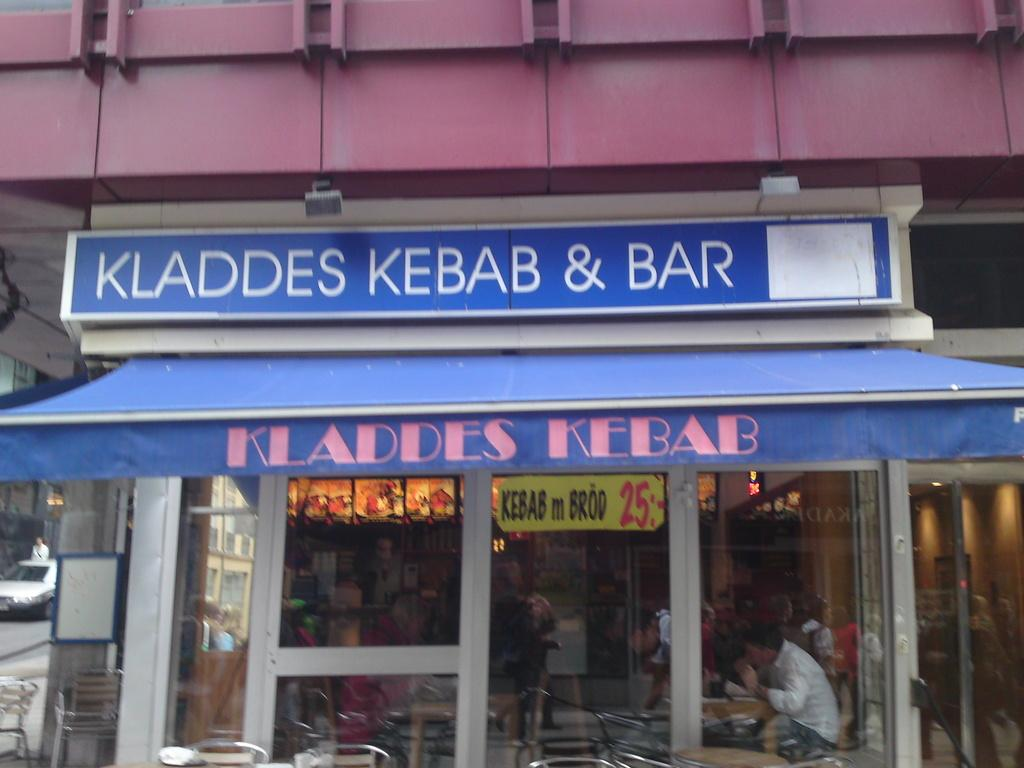What is the person in the shop doing? The person is sitting on a chair in the shop. Are there any chairs outside the shop? Yes, there are chairs in front of the shop. What can be seen on the left side of the shop? There is a car parked on the road on the left side of the shop. What type of invention is being demonstrated in the shop? There is no invention being demonstrated in the shop; the image only shows a person sitting on a chair and a car parked on the left side. Can you see any feathers or beds in the image? No, there are no feathers or beds present in the image. 